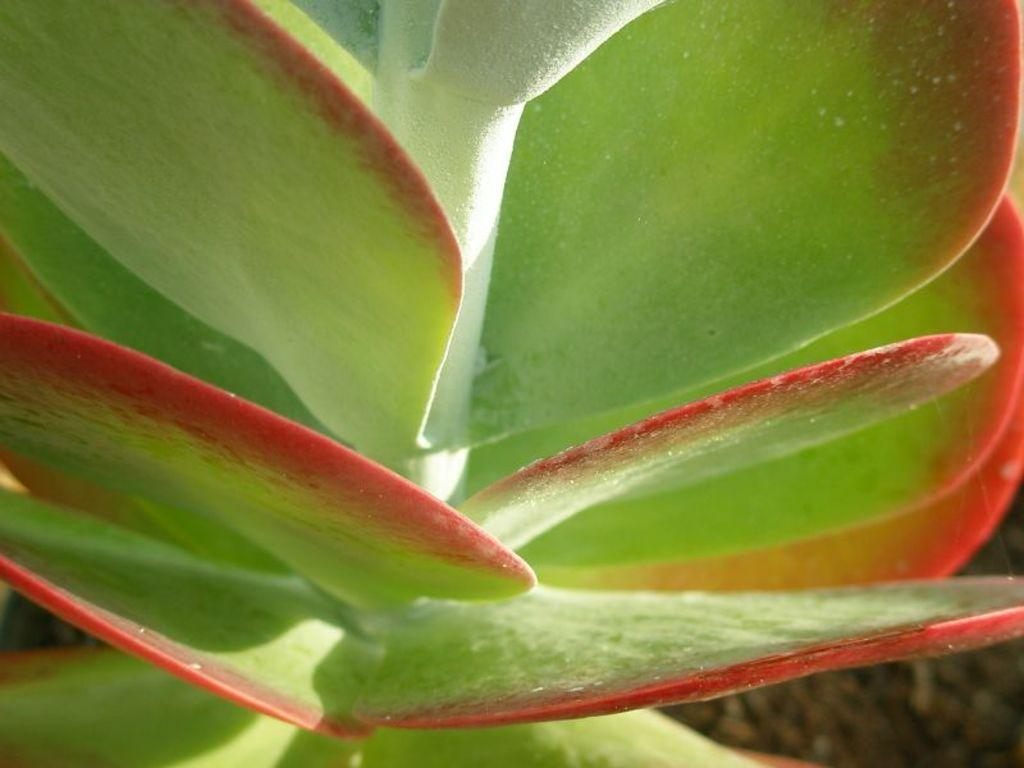What is the main subject of the image? The main subject of the image is a plant. What can be observed about the plant's leaves? The plant has green leaves. Who is the creator of the structure visible in the image? There is no structure visible in the image, only a plant with green leaves. 